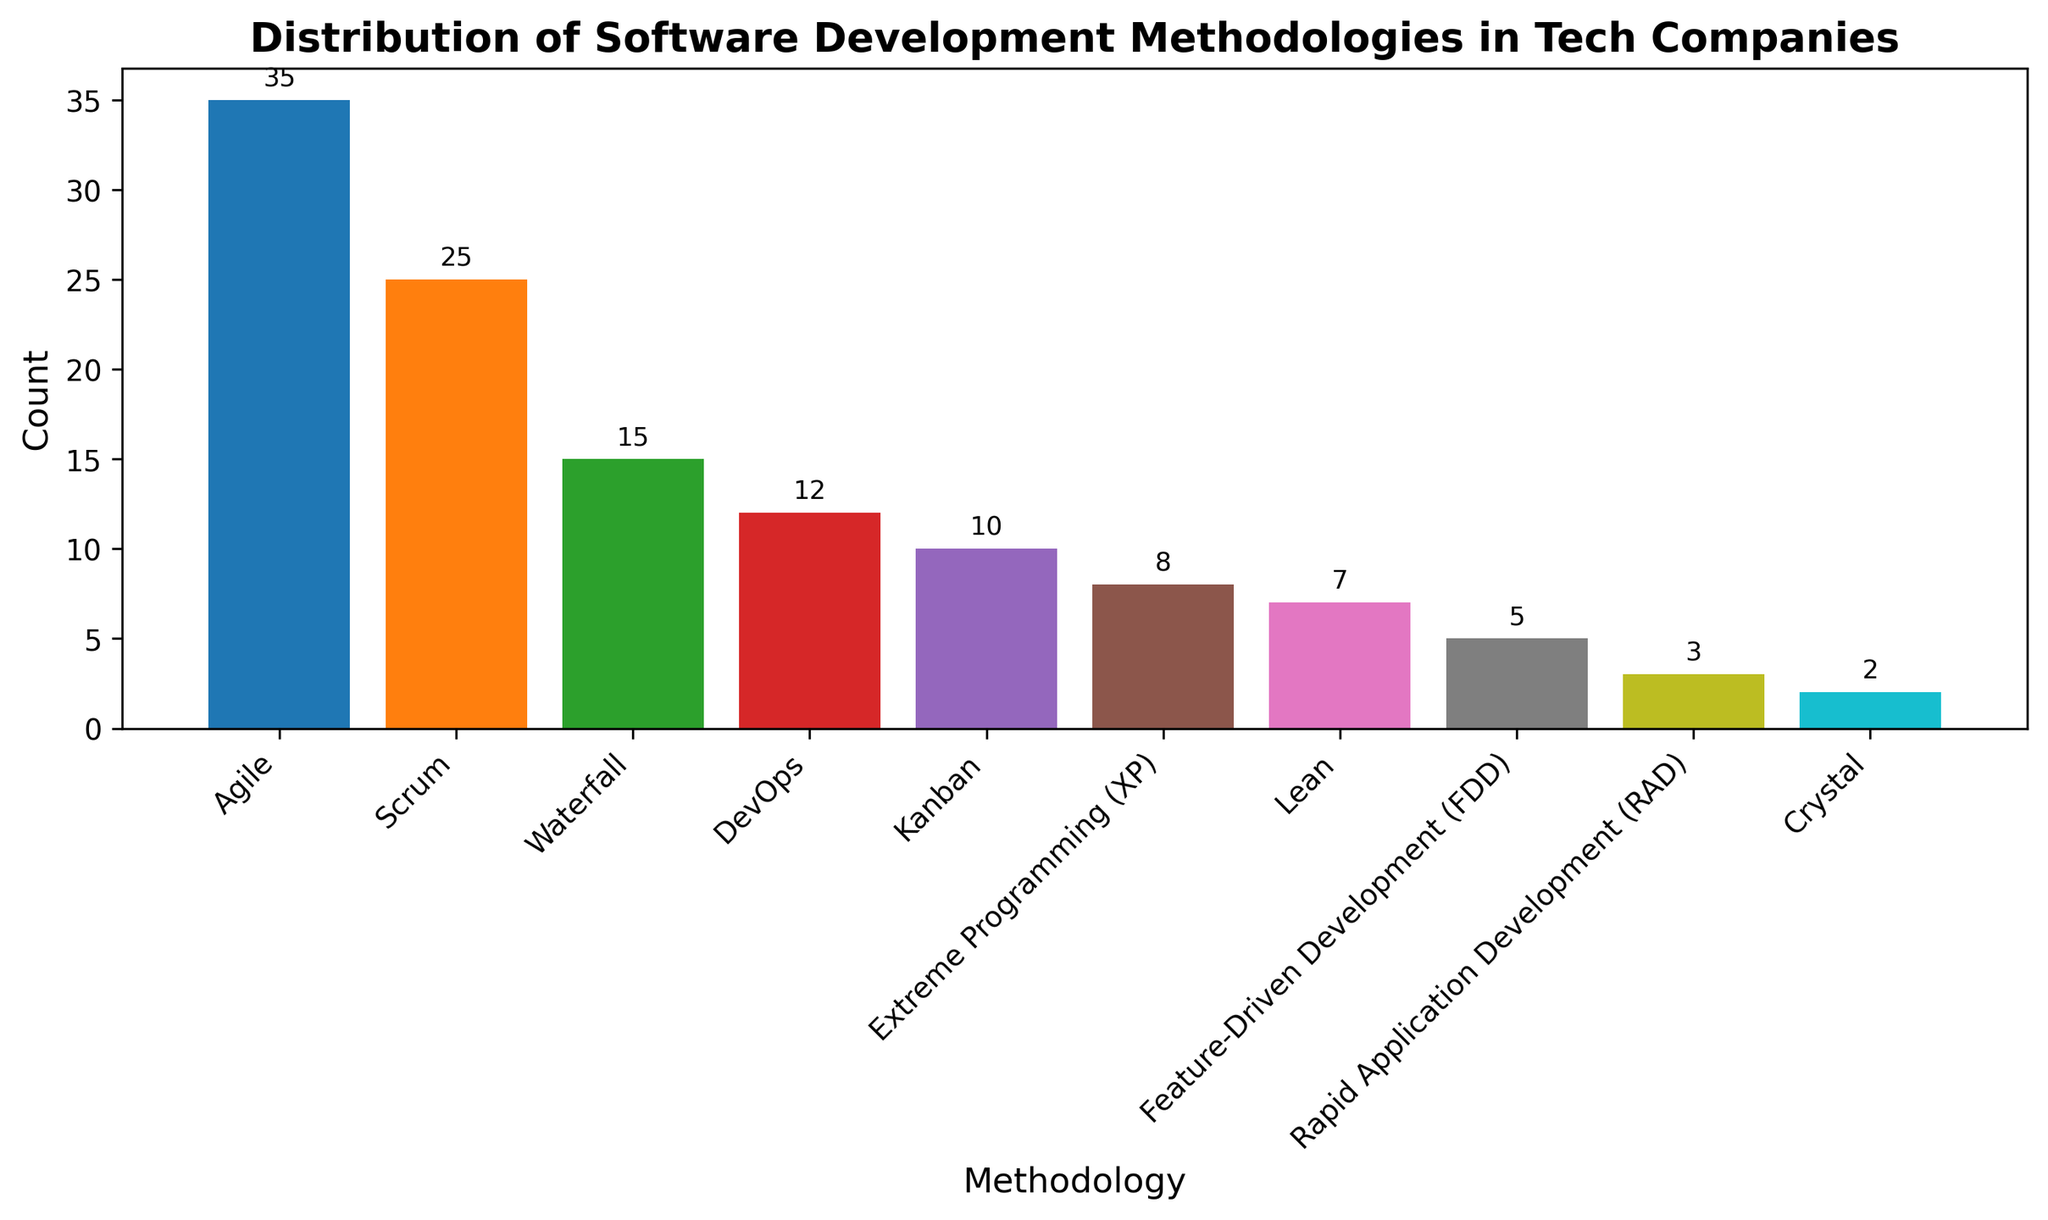What's the most commonly used software development methodology among the listed ones? The tallest bar in the bar chart represents the most commonly used methodology. In this case, the bar for Agile is the tallest with a count of 35.
Answer: Agile Which methodology is used less frequently, Kanban or DevOps? Comparing the heights of the bars for Kanban and DevOps, Kanban has a count of 10 while DevOps has a count of 12.
Answer: Kanban By how much does the count of Agile exceed the count of Waterfall? The figure shows Agile has a count of 35 and Waterfall has a count of 15. The difference is 35 - 15.
Answer: 20 What is the total count of companies using Agile, Scrum, and Kanban? Adding the counts from the chart: Agile (35) + Scrum (25) + Kanban (10) = 70.
Answer: 70 Which methodologies are used by fewer companies than Kanban? Kanban has a count of 10. All methodologies with counts less than 10 are Extreme Programming (XP) with 8, Lean with 7, Feature-Driven Development (FDD) with 5, Rapid Application Development (RAD) with 3, and Crystal with 2.
Answer: Extreme Programming (XP), Lean, Feature-Driven Development (FDD), Rapid Application Development (RAD), Crystal What is the combined count of companies using the bottom three methodologies? The bottom three methodologies are Feature-Driven Development (FDD) with 5, Rapid Application Development (RAD) with 3, and Crystal with 2. The combined count is 5 + 3 + 2.
Answer: 10 Which color represents the Scrum methodology on the chart? Each bar is colored differently, colors are filled according to the bar's order. Scrum, as the second bar, follows the color sequence typically used by the 'tab10' colormap, which transitions from blue to orange. Scrum is represented by the second color in the sequence, which is usually orange.
Answer: Orange Which two methodologies have the closest counts, and what are their counts? Comparing the heights of adjacent bars, DevOps has 12, and Kanban has 10, with a difference of just 2.
Answer: DevOps (12) and Kanban (10) What is the average count of all methodologies displayed in the bar chart? Sum the counts of all methodologies: 35 + 25 + 15 + 10 + 8 + 7 + 12 + 5 + 3 + 2 = 122. There are 10 methodologies, so the average is 122 / 10.
Answer: 12.2 Which methodology shows the second-lowest count, and what is the count? From the sorted list, the second-lowest bar represents Rapid Application Development (RAD) with a count of 3.
Answer: Rapid Application Development (RAD) (3) 